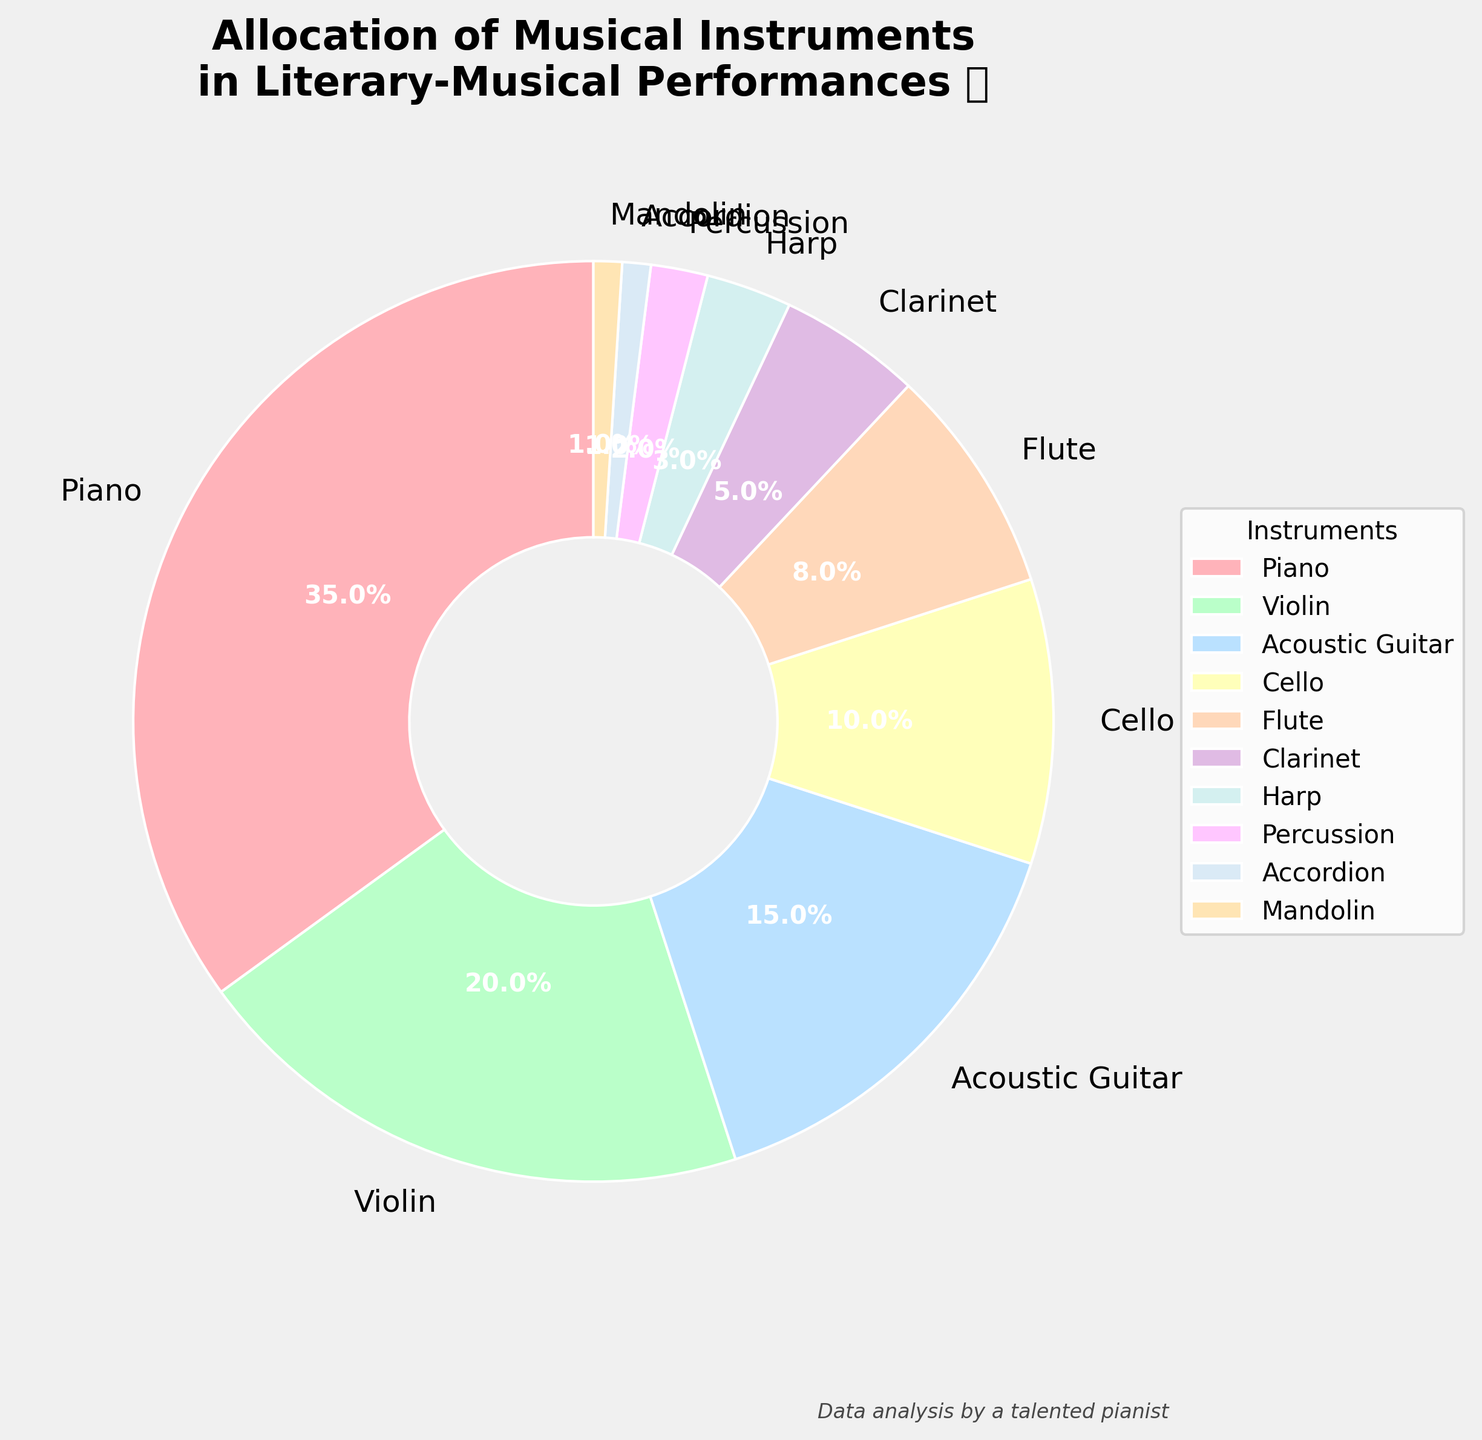What instrument has the largest percentage allocation? The instrument with the largest percentage allocation is the one with the highest number in the pie chart. Referring to the chart, the piano has the largest slice, labeled as 35%.
Answer: Piano Which two instruments have a combined percentage of 25%? To find this, identify instruments whose percentages add up to 25. The violin and acoustic guitar have percentages of 20% and 15% respectively, thus their combined percentage is 35%. However, looking through the available, the closest pair that adds up exactly to 25% is not applicable, so the possible combination beyond this condition will accumulate over 25%.
Answer: Violin and Acoustic Guitar How much more percentage does the piano have compared to the flute? Subtract the flute's percentage from the piano's. Piano has 35% and flute has 8%. Therefore, 35% - 8% = 27%.
Answer: 27% What is the total percentage allocated to stringed instruments (Piano, Violin, Acoustic Guitar, Cello, Harp, Mandolin)? Summing the percentages of these instruments: 35% (Piano) + 20% (Violin) + 15% (Acoustic Guitar) + 10% (Cello) + 3% (Harp) + 1% (Mandolin) = 84%.
Answer: 84% Which instruments have a percentage less than 5%? Identify the instruments labeled with percentages lower than 5%. These are Clarinet (5%), Harp (3%), Percussion (2%), Accordion (1%), and Mandolin (1%).
Answer: Harp, Percussion, Accordion, Mandolin Is the combined percentage of flute and clarinet greater than that of cello? Summing flute and clarinet’s percentages: 8% (Flute) + 5% (Clarinet) = 13%. Comparing this to cello’s percentage, which is 10%. Since 13% > 10%, the combined percentage is indeed greater.
Answer: Yes What’s the difference in percentage between acoustic guitar and percussion? Subtract the percussion's percentage from the acoustic guitar's. Acoustic guitar has 15%, and percussion has 2%. Therefore, 15% - 2% = 13%.
Answer: 13% Which instrument is represented by the smallest slice? The smallest percentage slice represents the instrument with the least allocation. Referring to the chart, both accordion and mandolin share the smallest slice at 1% each.
Answer: Accordion and Mandolin Is the proportion of stringed instruments more than 80%? Summing the percentages of Piano, Violin, Acoustic Guitar, Cello, Harp, and Mandolin gives us 84%, which is greater than 80%.
Answer: Yes 